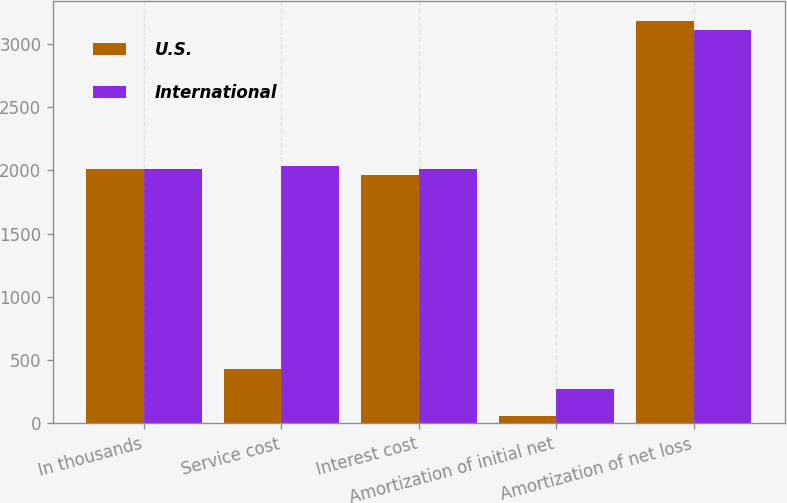Convert chart. <chart><loc_0><loc_0><loc_500><loc_500><stacked_bar_chart><ecel><fcel>In thousands<fcel>Service cost<fcel>Interest cost<fcel>Amortization of initial net<fcel>Amortization of net loss<nl><fcel>U.S.<fcel>2013<fcel>432<fcel>1960<fcel>62<fcel>3180<nl><fcel>International<fcel>2013<fcel>2035<fcel>2013<fcel>270<fcel>3107<nl></chart> 